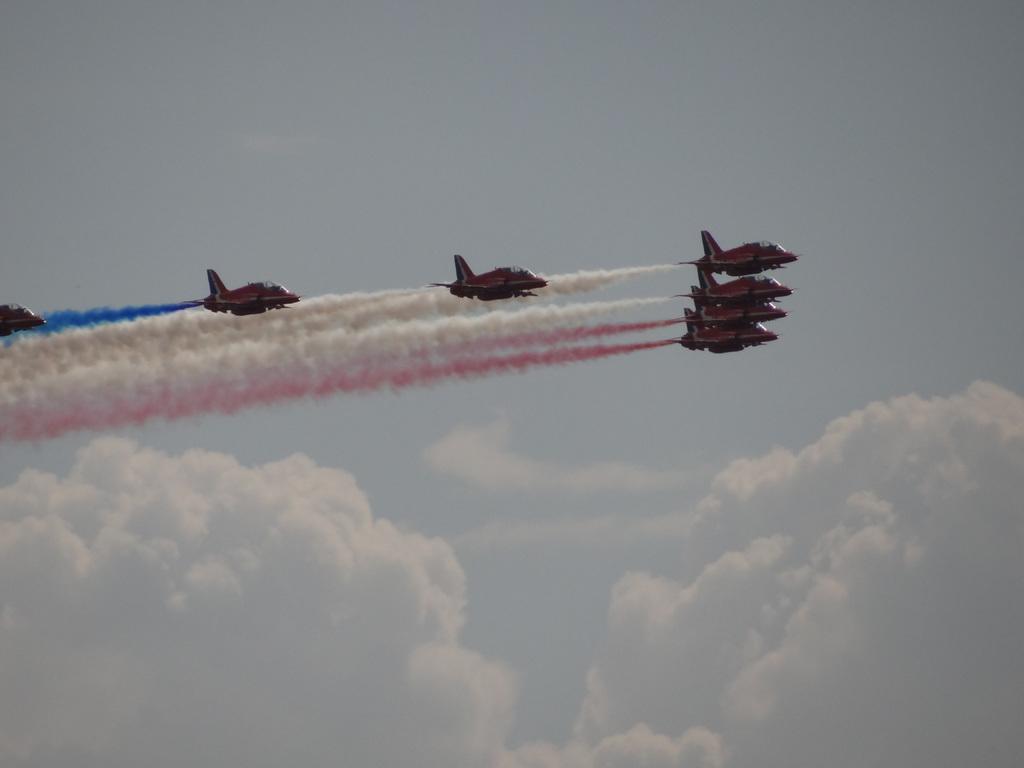Could you give a brief overview of what you see in this image? Here we can see airplanes flying in the air. In the background there is sky with clouds. 